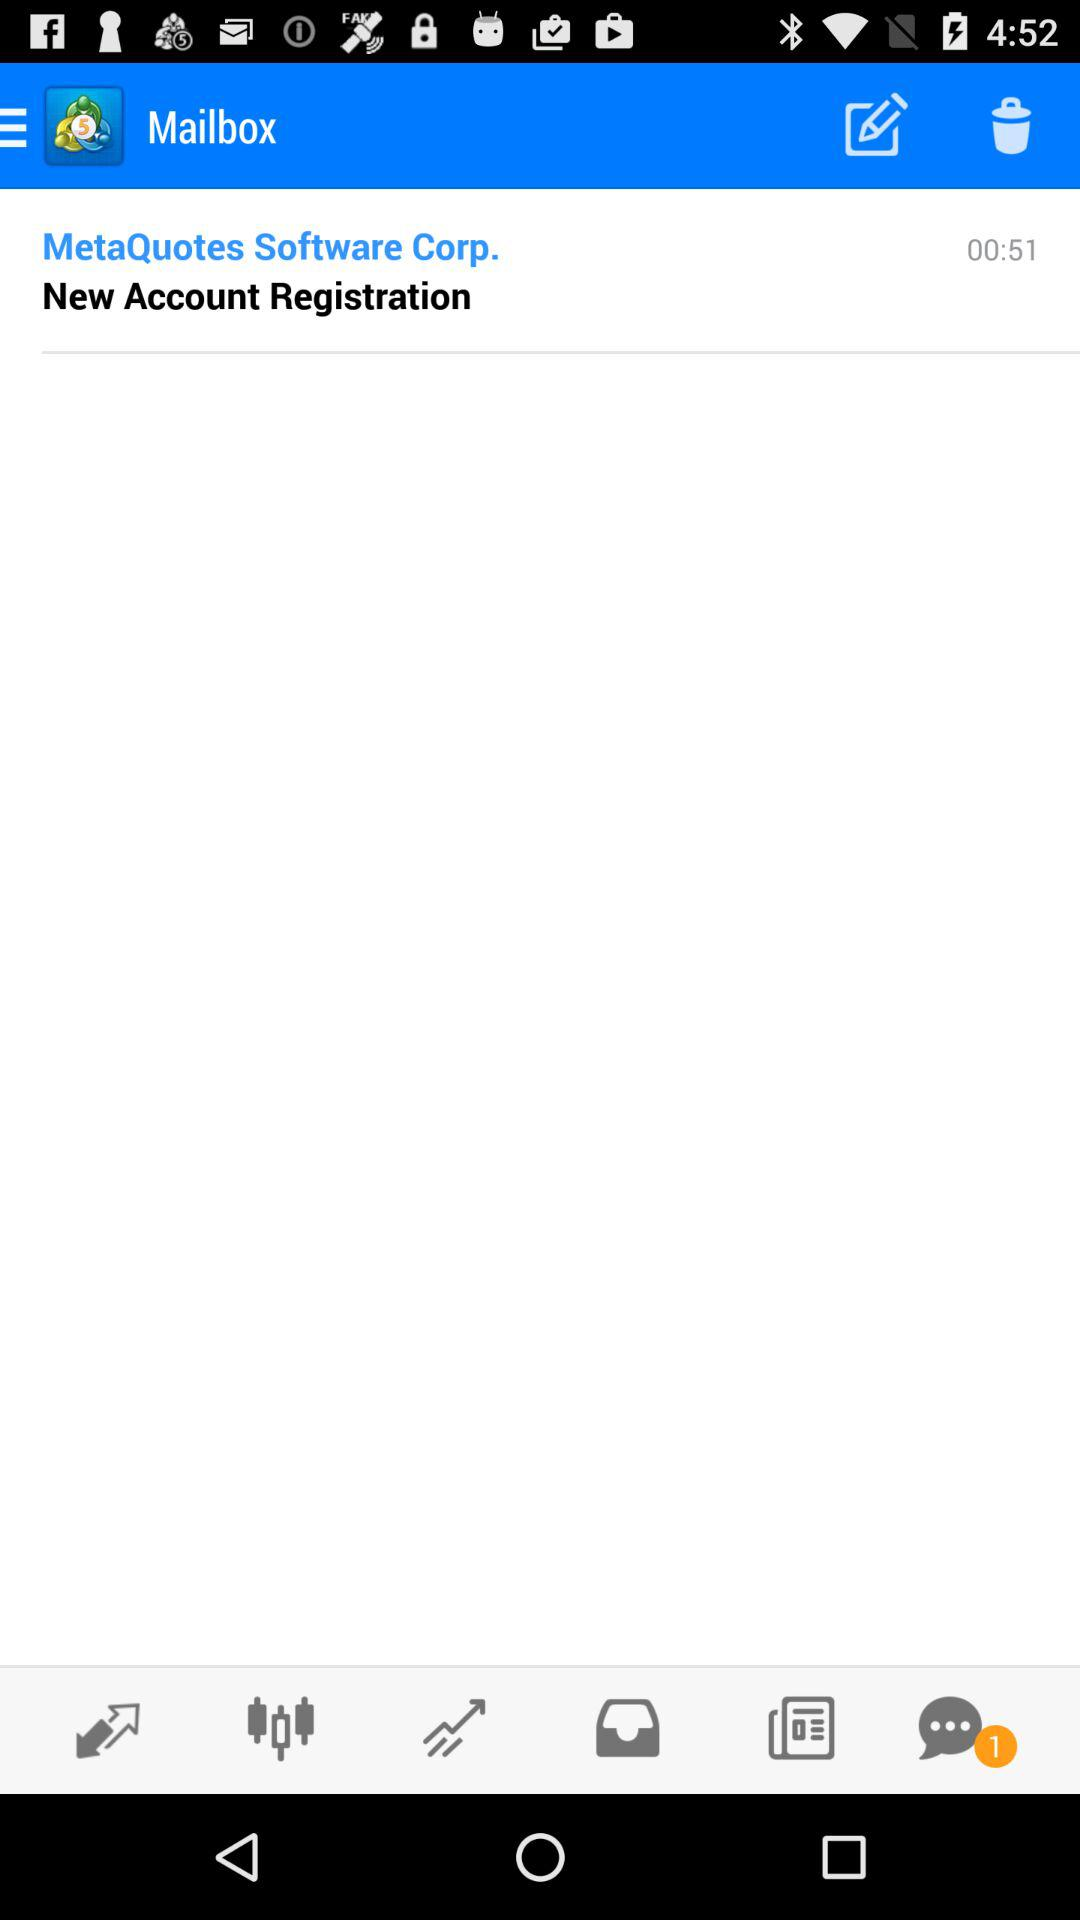How many minutes have passed since the last time the user logged in?
Answer the question using a single word or phrase. 00:51 